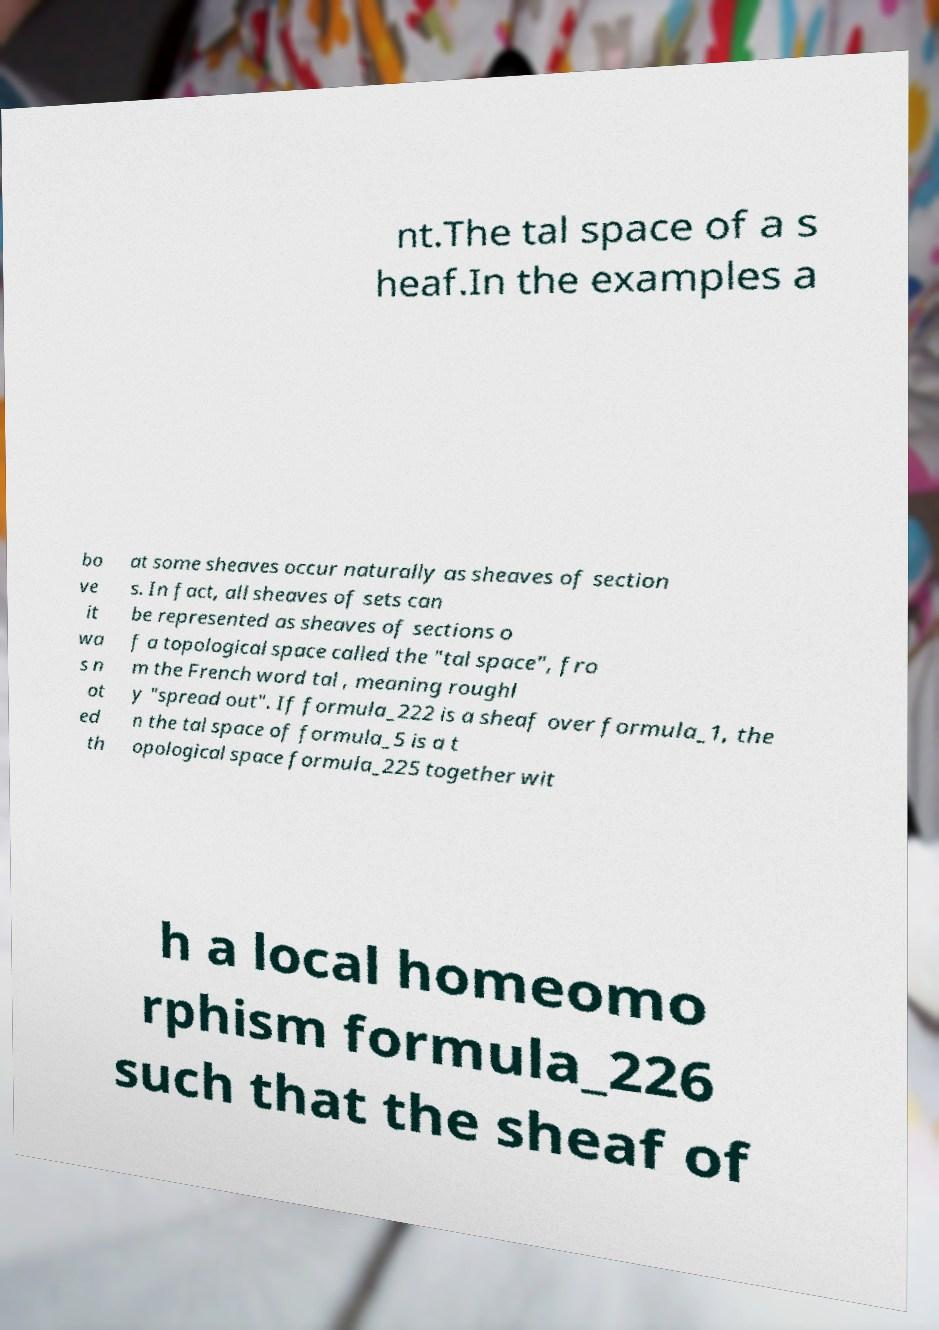For documentation purposes, I need the text within this image transcribed. Could you provide that? nt.The tal space of a s heaf.In the examples a bo ve it wa s n ot ed th at some sheaves occur naturally as sheaves of section s. In fact, all sheaves of sets can be represented as sheaves of sections o f a topological space called the "tal space", fro m the French word tal , meaning roughl y "spread out". If formula_222 is a sheaf over formula_1, the n the tal space of formula_5 is a t opological space formula_225 together wit h a local homeomo rphism formula_226 such that the sheaf of 